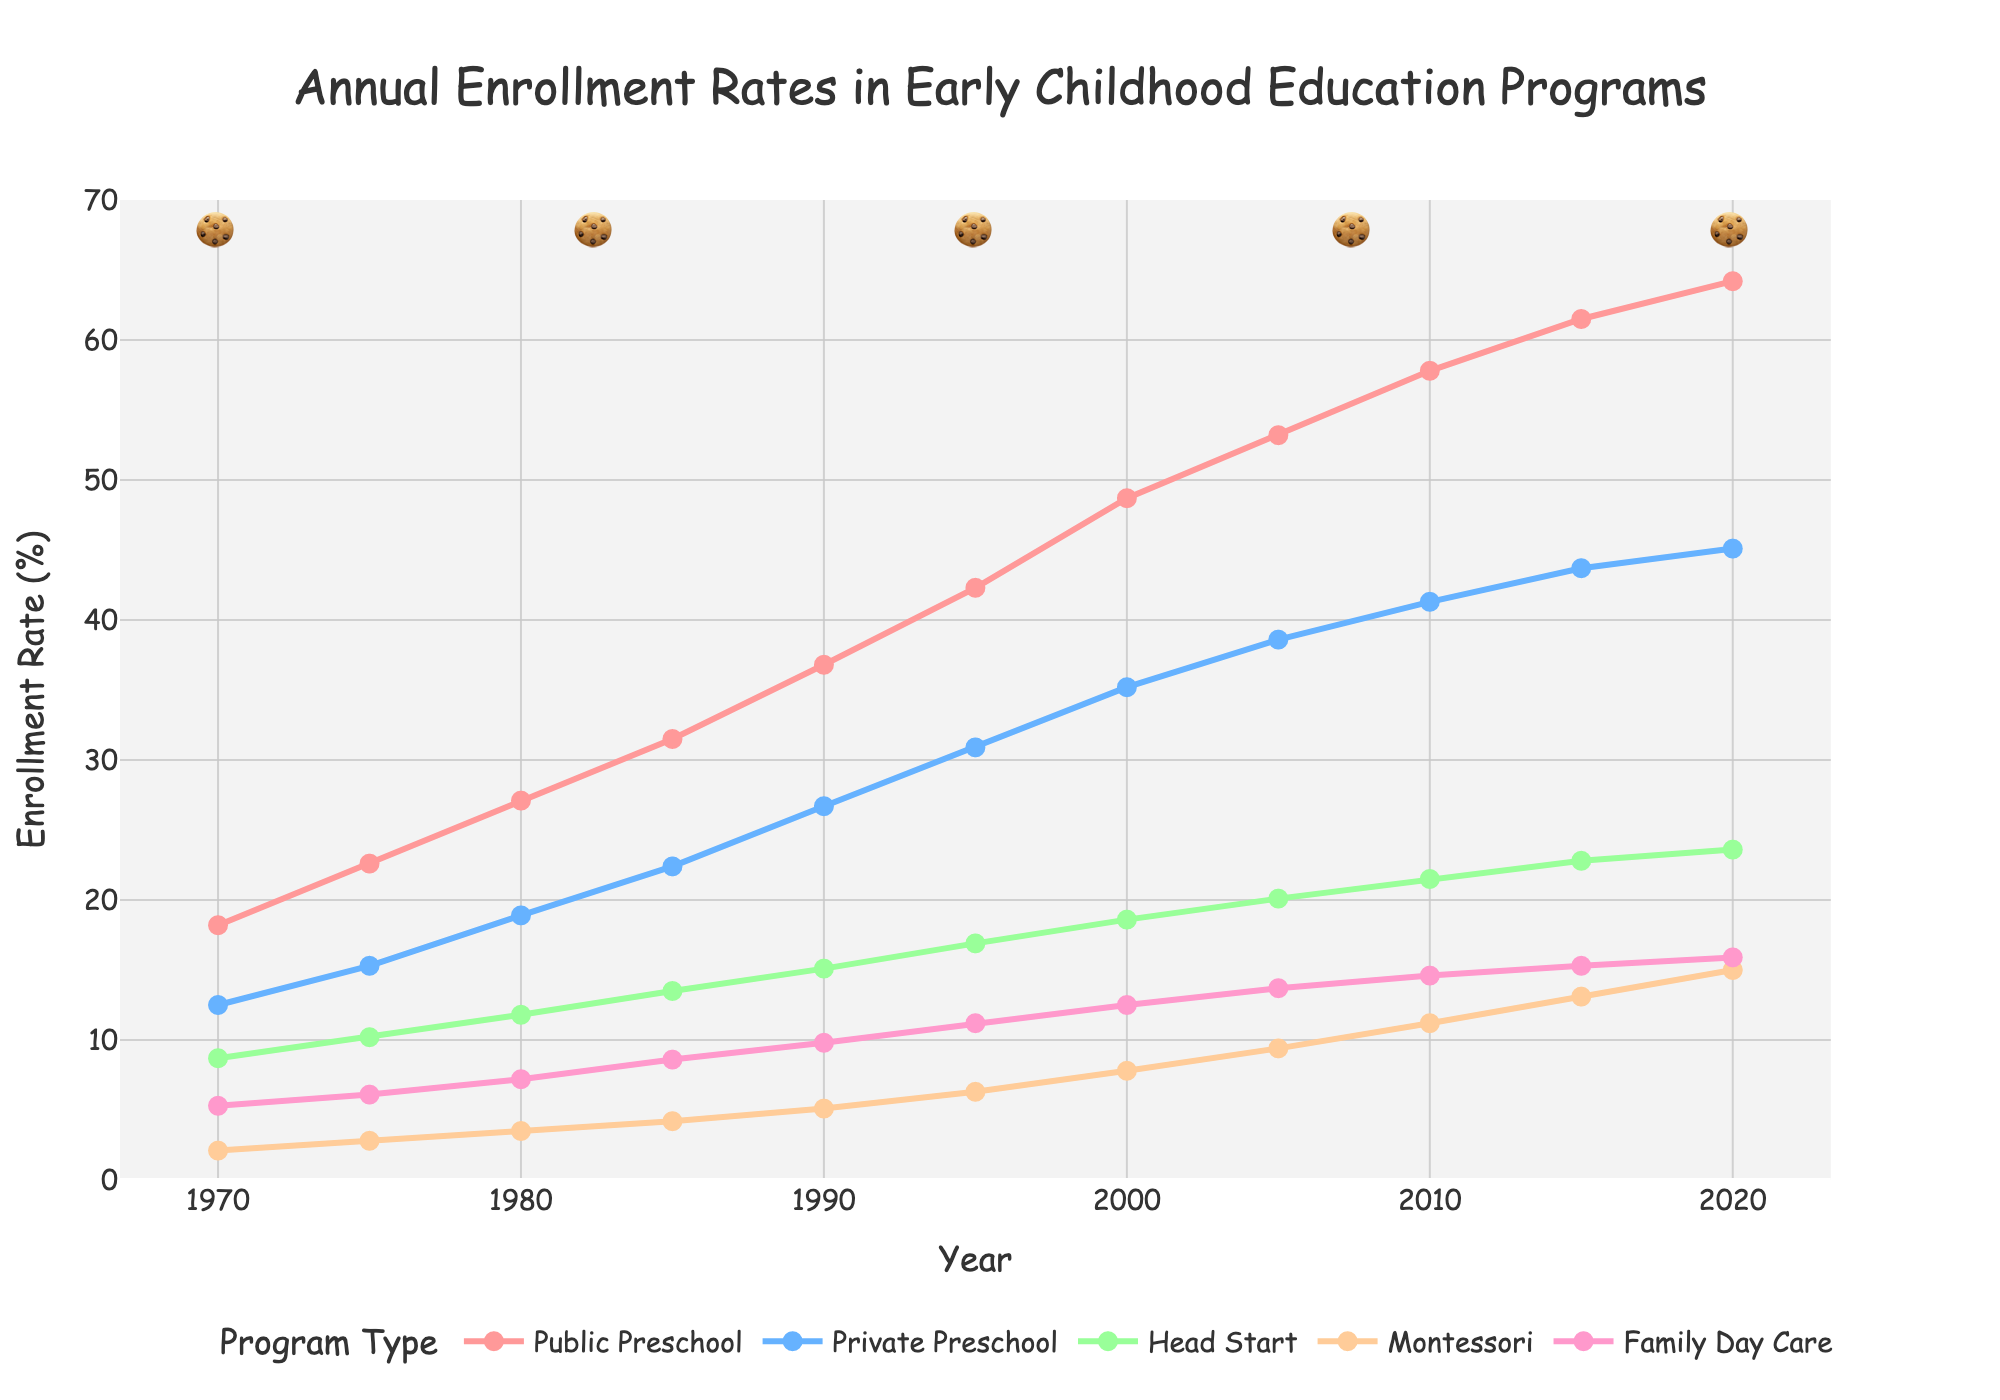What is the enrollment rate in Head Start programs in 1980? To find the enrollment rate, look at the intersection of the Head Start category and the year 1980. The value is in the dataset next to 1980 under Head Start.
Answer: 11.8% Which program had the highest enrollment rate in 2020? To determine the highest enrollment rate in 2020, compare all the values for the year 2020 across the different categories. The highest value is in the Public Preschool category.
Answer: Public Preschool Between 1975 and 1985, which program saw the highest percentage increase? Calculate the percentage increase for each program by subtracting the 1975 value from the 1985 value, then dividing by the 1975 value and multiplying by 100. The program with the highest percentage increase is Head Start ((13.5 - 10.2) / 10.2) * 100 ≈ 32.4%.
Answer: Head Start What is the combined enrollment rate of all programs in 1995? Sum the values for all programs in the year 1995 (42.3 + 30.9 + 16.9 + 6.3 + 11.2).
Answer: 107.6% Which program had the smallest increase in enrollment rate from 1970 to 2020? Calculate the increase for each program by subtracting the 1970 value from the 2020 value. The smallest increase is for Family Day Care (15.9 - 5.3) = 10.6.
Answer: Family Day Care Compare the enrollment rates of Montessori and Private Preschool programs in 2010. Which one is higher? Look at the values for Montessori and Private Preschool in 2010 and compare them. Montessori has an enrollment rate of 11.2, whereas Private Preschool has 41.3.
Answer: Private Preschool What was the average enrollment rate for Public Preschool between 1970 and 2020? Sum the enrollment rates of Public Preschool for all years and divide by the number of years (18.2 + 22.6 + 27.1 + 31.5 + 36.8 + 42.3 + 48.7 + 53.2 + 57.8 + 61.5 + 64.2 = 464.9, then 464.9/11).
Answer: 42.26% Compare the trends in enrollment rates for Public Preschool and Montessori programs from 1970 to 2020. Observe the slopes of the lines representing Public Preschool and Montessori. Public Preschool shows a steady increase, but Montessori increases more steeply after 2000, indicating a different growth pattern.
Answer: Public Preschool increased steadily, Montessori grew rapidly after 2000 Which year saw the highest enrollment rate in Family Day Care? Look at the values in the Family Day Care category and identify the highest value, which occurs in the year 2020.
Answer: 2020 